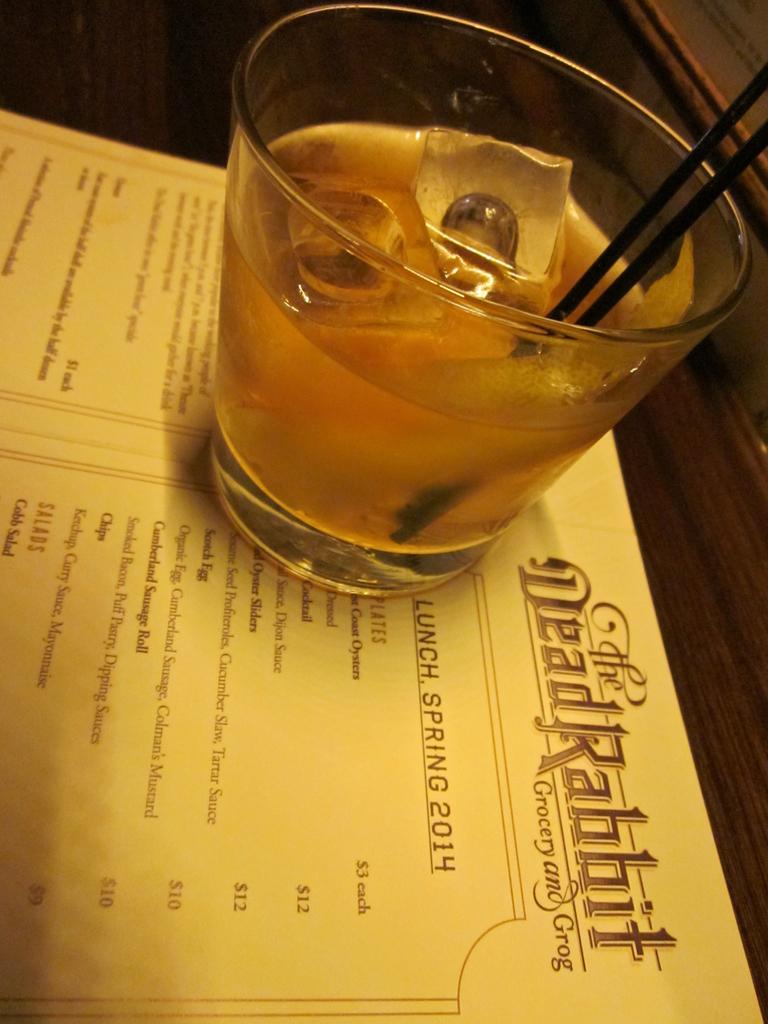What is the name of the establishment?
Provide a succinct answer. The dead rabbit. What year is on the menu?
Offer a terse response. 2014. 